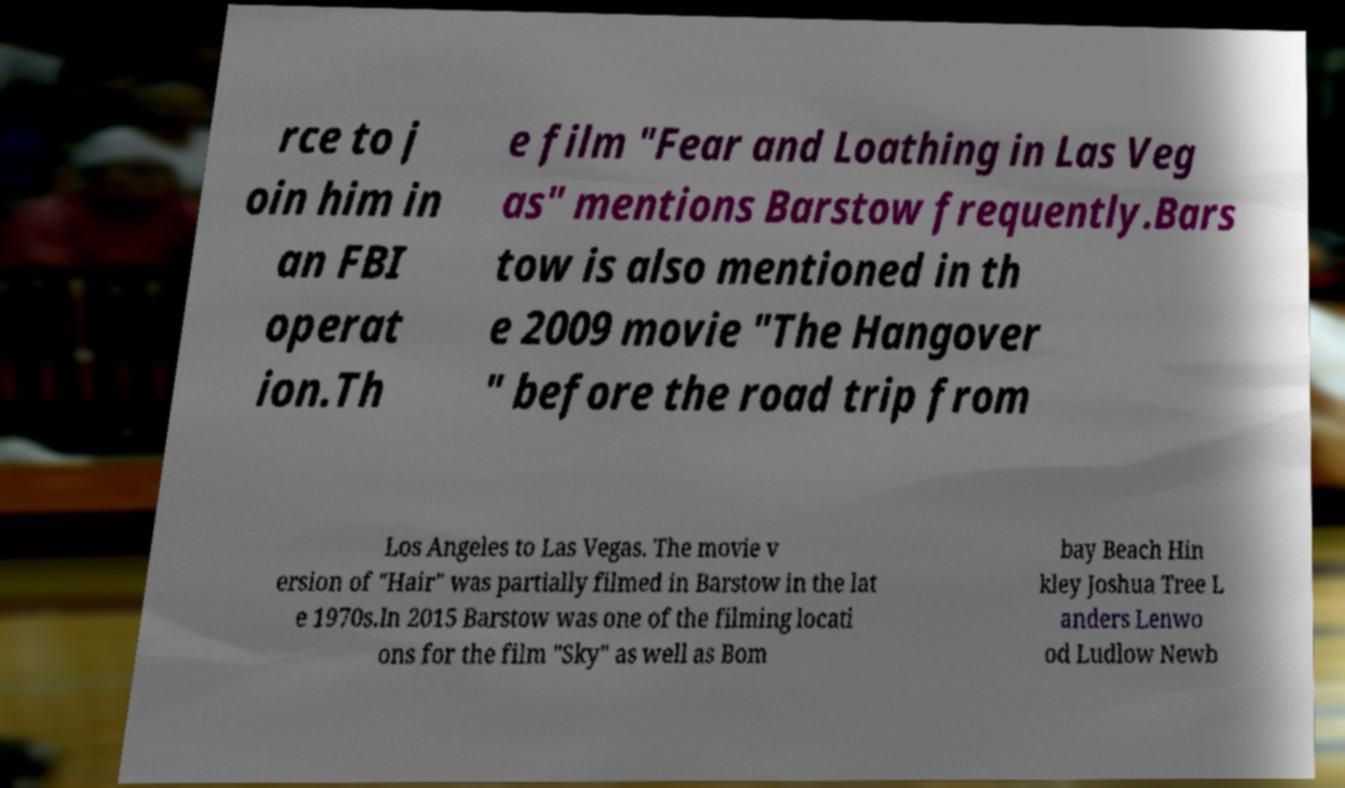For documentation purposes, I need the text within this image transcribed. Could you provide that? rce to j oin him in an FBI operat ion.Th e film "Fear and Loathing in Las Veg as" mentions Barstow frequently.Bars tow is also mentioned in th e 2009 movie "The Hangover " before the road trip from Los Angeles to Las Vegas. The movie v ersion of "Hair" was partially filmed in Barstow in the lat e 1970s.In 2015 Barstow was one of the filming locati ons for the film "Sky" as well as Bom bay Beach Hin kley Joshua Tree L anders Lenwo od Ludlow Newb 